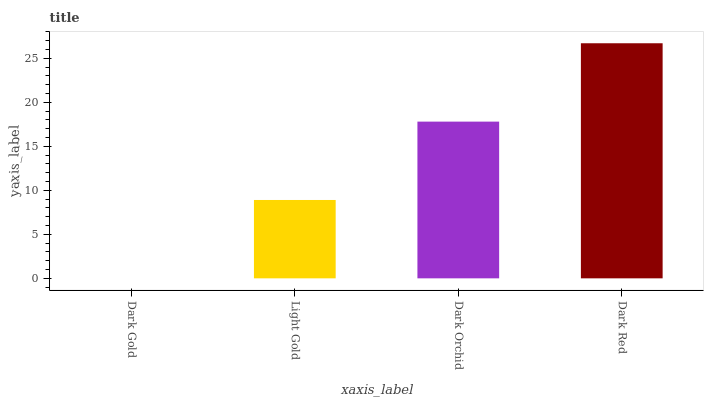Is Dark Gold the minimum?
Answer yes or no. Yes. Is Dark Red the maximum?
Answer yes or no. Yes. Is Light Gold the minimum?
Answer yes or no. No. Is Light Gold the maximum?
Answer yes or no. No. Is Light Gold greater than Dark Gold?
Answer yes or no. Yes. Is Dark Gold less than Light Gold?
Answer yes or no. Yes. Is Dark Gold greater than Light Gold?
Answer yes or no. No. Is Light Gold less than Dark Gold?
Answer yes or no. No. Is Dark Orchid the high median?
Answer yes or no. Yes. Is Light Gold the low median?
Answer yes or no. Yes. Is Light Gold the high median?
Answer yes or no. No. Is Dark Red the low median?
Answer yes or no. No. 